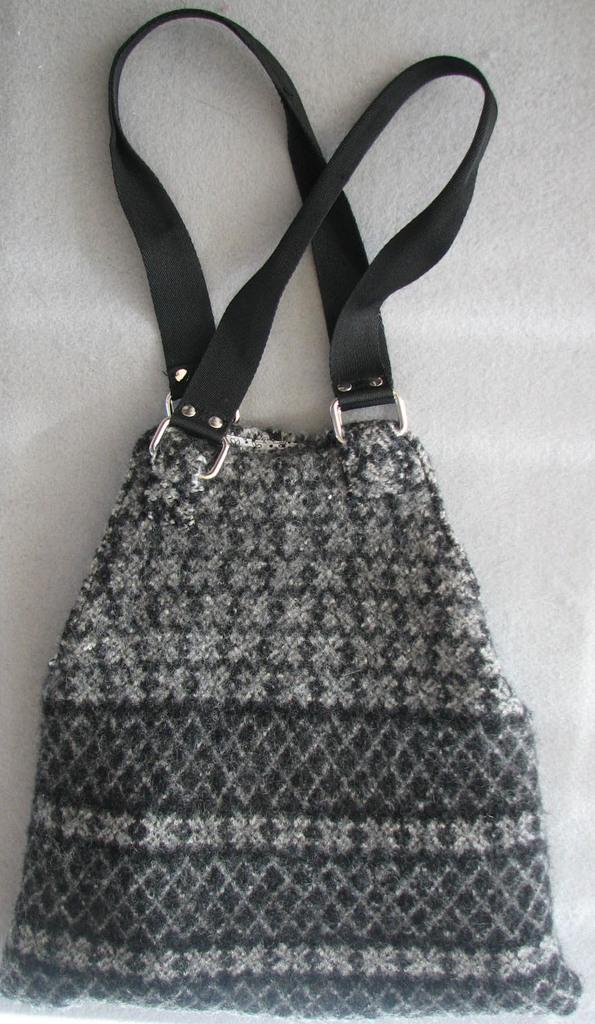What object is present in the image that can be used to carry items? The image contains a bag. What colors are used for the bag in the image? The bag is in white and black color. How many handles does the bag have? The bag has two handles. Can you see the thumb of the person holding the bag in the image? There is no person holding the bag in the image, so it is not possible to see their thumb. 